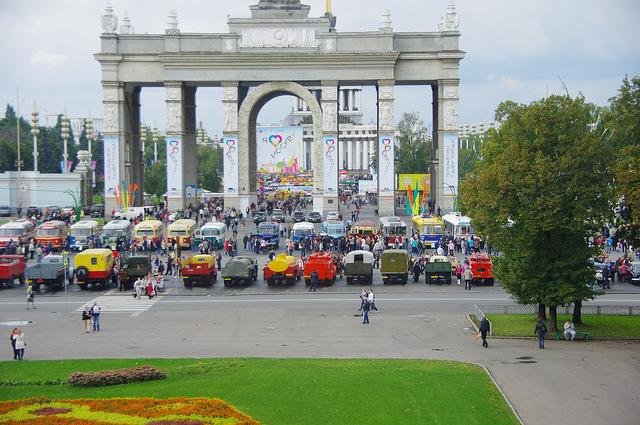Are all the vehicles buses?
Concise answer only. No. How many archways are built into the park entry?
Be succinct. 5. Where are the carefully manicured grounds?
Be succinct. Foreground. 